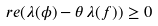Convert formula to latex. <formula><loc_0><loc_0><loc_500><loc_500>\ r e ( \lambda ( \phi ) - \theta \, \lambda ( f ) ) \geq 0</formula> 